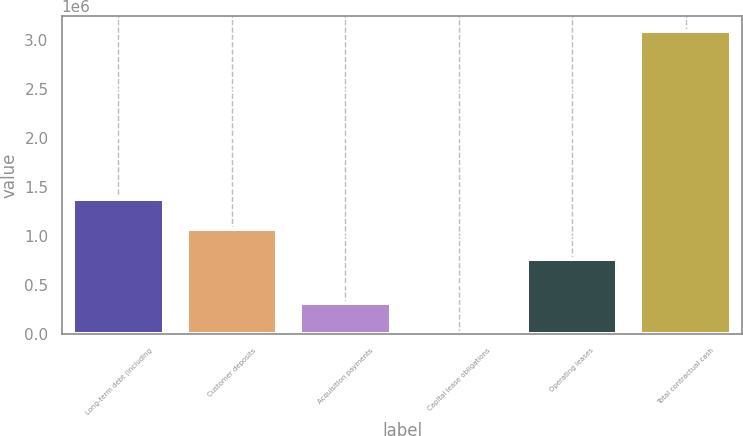Convert chart. <chart><loc_0><loc_0><loc_500><loc_500><bar_chart><fcel>Long-term debt (including<fcel>Customer deposits<fcel>Acquisition payments<fcel>Capital lease obligations<fcel>Operating leases<fcel>Total contractual cash<nl><fcel>1.37826e+06<fcel>1.07028e+06<fcel>319984<fcel>12001<fcel>762298<fcel>3.09183e+06<nl></chart> 